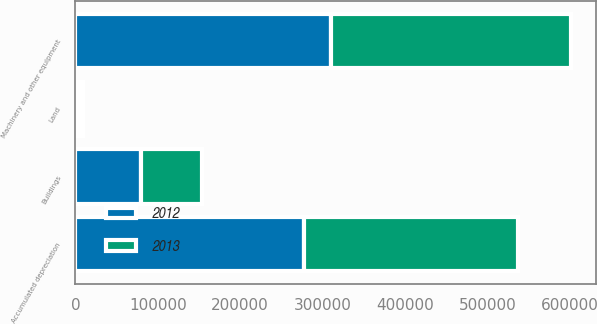Convert chart to OTSL. <chart><loc_0><loc_0><loc_500><loc_500><stacked_bar_chart><ecel><fcel>Land<fcel>Buildings<fcel>Machinery and other equipment<fcel>Accumulated depreciation<nl><fcel>2012<fcel>4384<fcel>79219<fcel>310738<fcel>277031<nl><fcel>2013<fcel>4308<fcel>74609<fcel>291004<fcel>259524<nl></chart> 